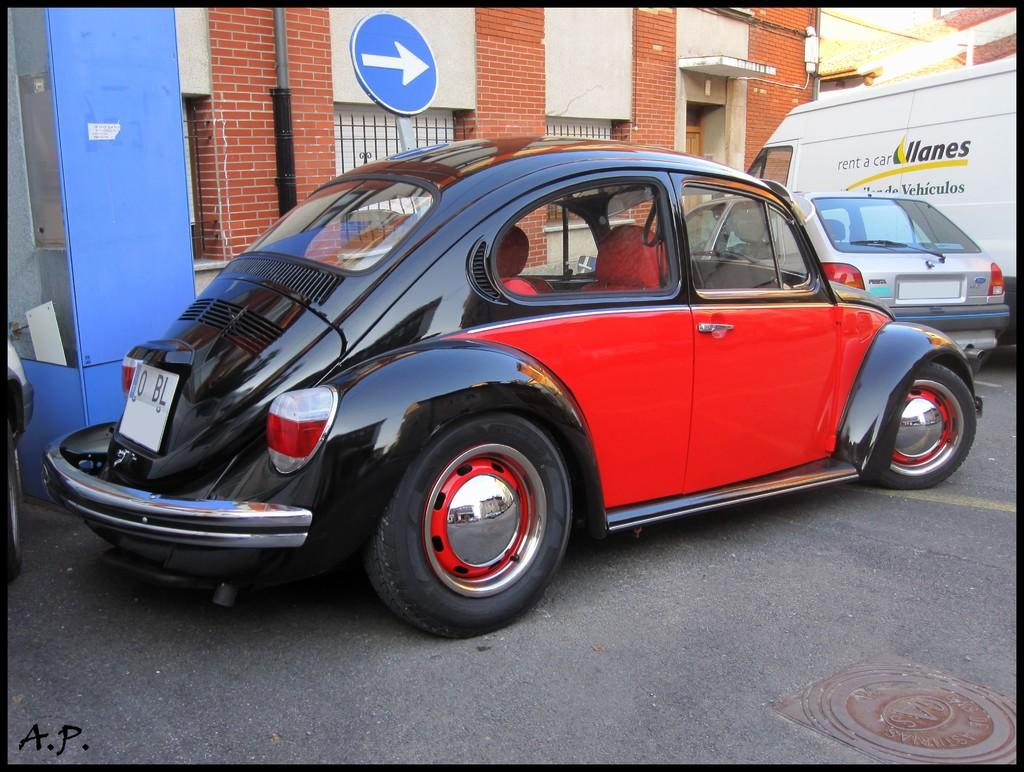What can be seen on the road in the image? There are vehicles on the road in the image. What is visible in the distance behind the vehicles? There are buildings, a pole, and a signboard in the background of the image. What structure can be seen in the image besides the vehicles and background elements? There is a booth in the image. What type of health advice is being given on the signboard in the image? There is no health advice present on the signboard in the image; it is a signboard with information or advertisements unrelated to health. 